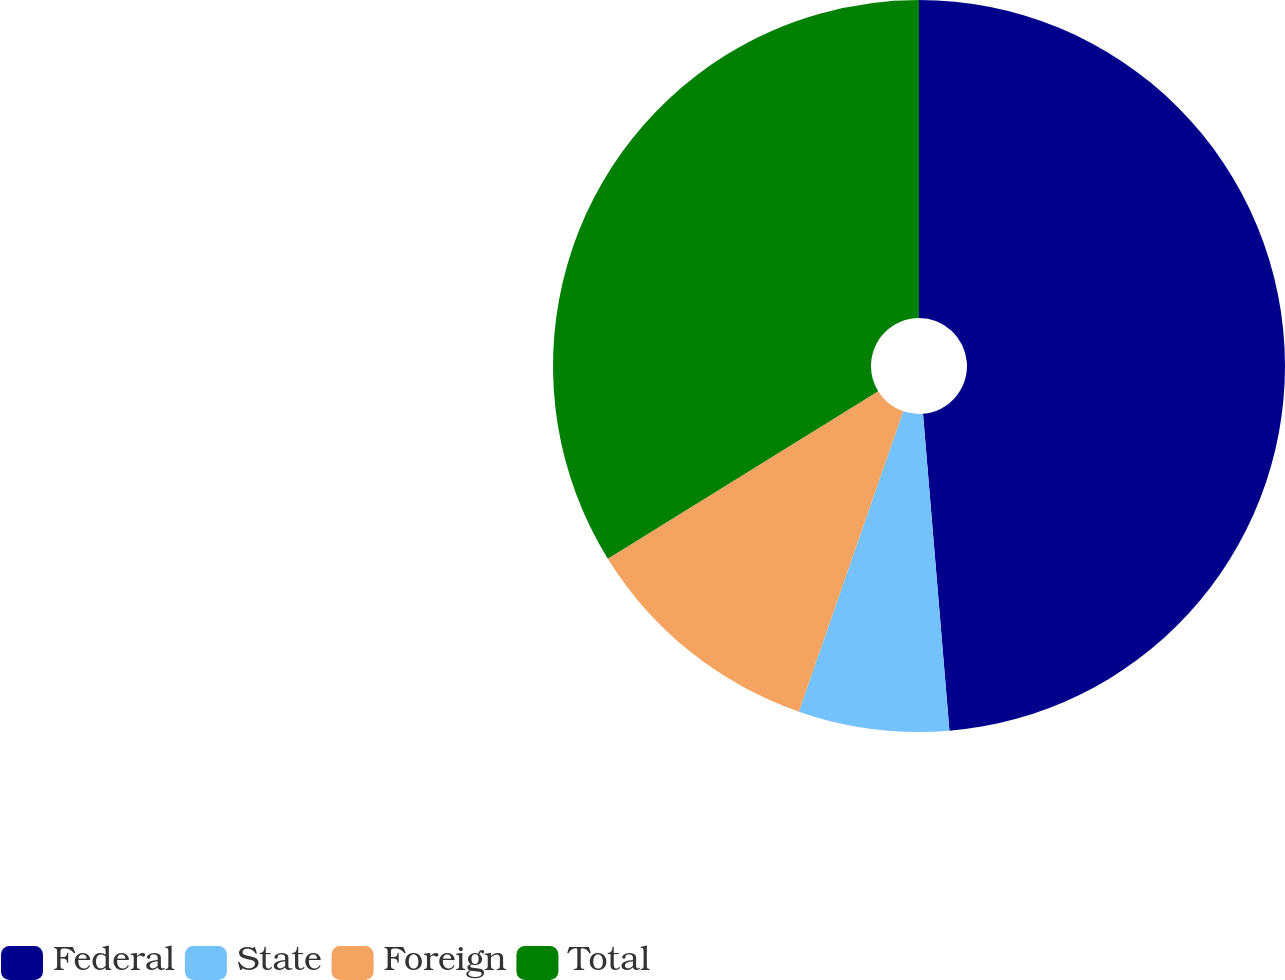Convert chart to OTSL. <chart><loc_0><loc_0><loc_500><loc_500><pie_chart><fcel>Federal<fcel>State<fcel>Foreign<fcel>Total<nl><fcel>48.67%<fcel>6.65%<fcel>10.85%<fcel>33.82%<nl></chart> 